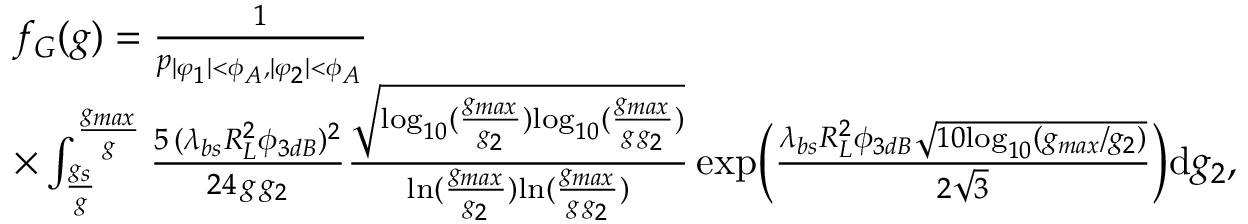Convert formula to latex. <formula><loc_0><loc_0><loc_500><loc_500>\begin{array} { r l } & { f _ { G } ( g ) = \frac { 1 } { p _ { | \varphi _ { 1 } | < \phi _ { A } , | \varphi _ { 2 } | < \phi _ { A } } } } \\ & { \times \int _ { \frac { g _ { s } } { g } } ^ { \frac { g _ { \max } } { g } } \frac { 5 \, ( \lambda _ { b s } R _ { L } ^ { 2 } \phi _ { 3 d B } ) ^ { 2 } } { 2 4 \, g \, g _ { 2 } } \frac { \sqrt { { \log } _ { 1 0 } ( \frac { g _ { \max } } { g _ { 2 } } ) { \log } _ { 1 0 } ( \frac { g _ { \max } } { g \, g _ { 2 } } ) } } { { \ln } ( \frac { g _ { \max } } { g _ { 2 } } ) { \ln } ( \frac { g _ { \max } } { g \, g _ { 2 } } ) } \, { e x p } \left ( \frac { \lambda _ { b s } R _ { L } ^ { 2 } \phi _ { 3 d B } \sqrt { 1 0 { \log } _ { 1 0 } ( g _ { \max } / g _ { 2 } ) } } { 2 \sqrt { 3 } } \right ) d g _ { 2 } , } \end{array}</formula> 